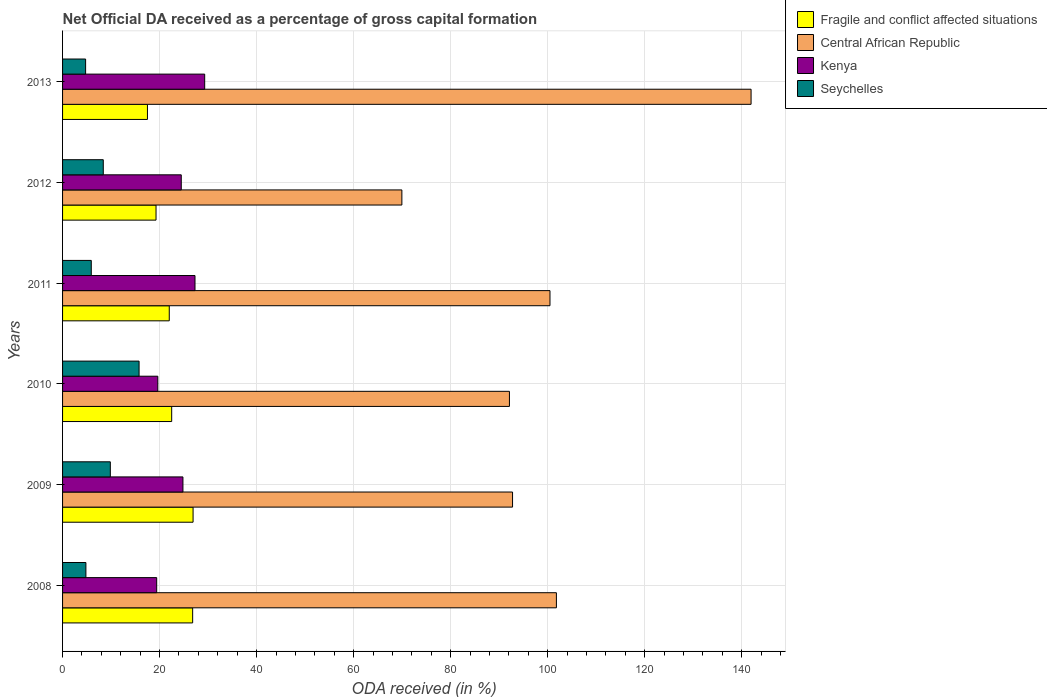How many groups of bars are there?
Ensure brevity in your answer.  6. Are the number of bars per tick equal to the number of legend labels?
Your answer should be very brief. Yes. How many bars are there on the 3rd tick from the bottom?
Offer a very short reply. 4. What is the net ODA received in Central African Republic in 2013?
Your response must be concise. 141.94. Across all years, what is the maximum net ODA received in Central African Republic?
Your answer should be very brief. 141.94. Across all years, what is the minimum net ODA received in Fragile and conflict affected situations?
Offer a very short reply. 17.5. In which year was the net ODA received in Central African Republic minimum?
Your response must be concise. 2012. What is the total net ODA received in Fragile and conflict affected situations in the graph?
Your answer should be very brief. 134.99. What is the difference between the net ODA received in Central African Republic in 2008 and that in 2009?
Offer a very short reply. 9.04. What is the difference between the net ODA received in Kenya in 2011 and the net ODA received in Central African Republic in 2012?
Provide a short and direct response. -42.65. What is the average net ODA received in Central African Republic per year?
Give a very brief answer. 99.85. In the year 2013, what is the difference between the net ODA received in Seychelles and net ODA received in Kenya?
Ensure brevity in your answer.  -24.55. In how many years, is the net ODA received in Kenya greater than 8 %?
Your answer should be very brief. 6. What is the ratio of the net ODA received in Seychelles in 2010 to that in 2013?
Offer a terse response. 3.32. Is the net ODA received in Fragile and conflict affected situations in 2010 less than that in 2013?
Your response must be concise. No. What is the difference between the highest and the second highest net ODA received in Kenya?
Offer a terse response. 2. What is the difference between the highest and the lowest net ODA received in Fragile and conflict affected situations?
Keep it short and to the point. 9.4. What does the 2nd bar from the top in 2009 represents?
Your response must be concise. Kenya. What does the 4th bar from the bottom in 2010 represents?
Ensure brevity in your answer.  Seychelles. How many bars are there?
Your answer should be compact. 24. Are all the bars in the graph horizontal?
Provide a short and direct response. Yes. How many years are there in the graph?
Ensure brevity in your answer.  6. Does the graph contain any zero values?
Keep it short and to the point. No. Where does the legend appear in the graph?
Your answer should be compact. Top right. What is the title of the graph?
Your answer should be very brief. Net Official DA received as a percentage of gross capital formation. Does "Denmark" appear as one of the legend labels in the graph?
Ensure brevity in your answer.  No. What is the label or title of the X-axis?
Make the answer very short. ODA received (in %). What is the ODA received (in %) of Fragile and conflict affected situations in 2008?
Offer a terse response. 26.82. What is the ODA received (in %) in Central African Republic in 2008?
Your answer should be very brief. 101.81. What is the ODA received (in %) of Kenya in 2008?
Ensure brevity in your answer.  19.4. What is the ODA received (in %) of Seychelles in 2008?
Offer a terse response. 4.81. What is the ODA received (in %) of Fragile and conflict affected situations in 2009?
Your answer should be very brief. 26.91. What is the ODA received (in %) in Central African Republic in 2009?
Your answer should be very brief. 92.77. What is the ODA received (in %) in Kenya in 2009?
Provide a succinct answer. 24.82. What is the ODA received (in %) of Seychelles in 2009?
Ensure brevity in your answer.  9.85. What is the ODA received (in %) in Fragile and conflict affected situations in 2010?
Offer a very short reply. 22.5. What is the ODA received (in %) of Central African Republic in 2010?
Your answer should be compact. 92.13. What is the ODA received (in %) in Kenya in 2010?
Your answer should be compact. 19.64. What is the ODA received (in %) of Seychelles in 2010?
Provide a succinct answer. 15.78. What is the ODA received (in %) of Fragile and conflict affected situations in 2011?
Your answer should be very brief. 22. What is the ODA received (in %) in Central African Republic in 2011?
Provide a short and direct response. 100.49. What is the ODA received (in %) of Kenya in 2011?
Ensure brevity in your answer.  27.3. What is the ODA received (in %) of Seychelles in 2011?
Offer a very short reply. 5.92. What is the ODA received (in %) of Fragile and conflict affected situations in 2012?
Ensure brevity in your answer.  19.27. What is the ODA received (in %) in Central African Republic in 2012?
Offer a terse response. 69.95. What is the ODA received (in %) of Kenya in 2012?
Your response must be concise. 24.47. What is the ODA received (in %) in Seychelles in 2012?
Provide a succinct answer. 8.39. What is the ODA received (in %) of Fragile and conflict affected situations in 2013?
Your answer should be compact. 17.5. What is the ODA received (in %) in Central African Republic in 2013?
Your response must be concise. 141.94. What is the ODA received (in %) in Kenya in 2013?
Offer a terse response. 29.3. What is the ODA received (in %) of Seychelles in 2013?
Provide a short and direct response. 4.75. Across all years, what is the maximum ODA received (in %) in Fragile and conflict affected situations?
Offer a very short reply. 26.91. Across all years, what is the maximum ODA received (in %) of Central African Republic?
Your answer should be very brief. 141.94. Across all years, what is the maximum ODA received (in %) in Kenya?
Provide a short and direct response. 29.3. Across all years, what is the maximum ODA received (in %) of Seychelles?
Give a very brief answer. 15.78. Across all years, what is the minimum ODA received (in %) in Fragile and conflict affected situations?
Provide a short and direct response. 17.5. Across all years, what is the minimum ODA received (in %) of Central African Republic?
Offer a terse response. 69.95. Across all years, what is the minimum ODA received (in %) in Kenya?
Provide a succinct answer. 19.4. Across all years, what is the minimum ODA received (in %) in Seychelles?
Provide a short and direct response. 4.75. What is the total ODA received (in %) of Fragile and conflict affected situations in the graph?
Provide a succinct answer. 134.99. What is the total ODA received (in %) in Central African Republic in the graph?
Offer a terse response. 599.08. What is the total ODA received (in %) of Kenya in the graph?
Your answer should be compact. 144.93. What is the total ODA received (in %) in Seychelles in the graph?
Give a very brief answer. 49.49. What is the difference between the ODA received (in %) in Fragile and conflict affected situations in 2008 and that in 2009?
Your answer should be compact. -0.09. What is the difference between the ODA received (in %) in Central African Republic in 2008 and that in 2009?
Offer a very short reply. 9.04. What is the difference between the ODA received (in %) in Kenya in 2008 and that in 2009?
Give a very brief answer. -5.41. What is the difference between the ODA received (in %) in Seychelles in 2008 and that in 2009?
Provide a short and direct response. -5.04. What is the difference between the ODA received (in %) in Fragile and conflict affected situations in 2008 and that in 2010?
Provide a succinct answer. 4.32. What is the difference between the ODA received (in %) of Central African Republic in 2008 and that in 2010?
Give a very brief answer. 9.68. What is the difference between the ODA received (in %) in Kenya in 2008 and that in 2010?
Your answer should be very brief. -0.23. What is the difference between the ODA received (in %) of Seychelles in 2008 and that in 2010?
Provide a succinct answer. -10.96. What is the difference between the ODA received (in %) in Fragile and conflict affected situations in 2008 and that in 2011?
Keep it short and to the point. 4.82. What is the difference between the ODA received (in %) in Central African Republic in 2008 and that in 2011?
Your response must be concise. 1.32. What is the difference between the ODA received (in %) of Kenya in 2008 and that in 2011?
Keep it short and to the point. -7.9. What is the difference between the ODA received (in %) of Seychelles in 2008 and that in 2011?
Your answer should be compact. -1.11. What is the difference between the ODA received (in %) in Fragile and conflict affected situations in 2008 and that in 2012?
Give a very brief answer. 7.55. What is the difference between the ODA received (in %) of Central African Republic in 2008 and that in 2012?
Offer a very short reply. 31.86. What is the difference between the ODA received (in %) of Kenya in 2008 and that in 2012?
Ensure brevity in your answer.  -5.07. What is the difference between the ODA received (in %) in Seychelles in 2008 and that in 2012?
Give a very brief answer. -3.58. What is the difference between the ODA received (in %) of Fragile and conflict affected situations in 2008 and that in 2013?
Your response must be concise. 9.32. What is the difference between the ODA received (in %) of Central African Republic in 2008 and that in 2013?
Ensure brevity in your answer.  -40.13. What is the difference between the ODA received (in %) in Kenya in 2008 and that in 2013?
Your response must be concise. -9.9. What is the difference between the ODA received (in %) of Seychelles in 2008 and that in 2013?
Make the answer very short. 0.06. What is the difference between the ODA received (in %) in Fragile and conflict affected situations in 2009 and that in 2010?
Your answer should be compact. 4.41. What is the difference between the ODA received (in %) in Central African Republic in 2009 and that in 2010?
Provide a short and direct response. 0.64. What is the difference between the ODA received (in %) of Kenya in 2009 and that in 2010?
Offer a terse response. 5.18. What is the difference between the ODA received (in %) of Seychelles in 2009 and that in 2010?
Make the answer very short. -5.93. What is the difference between the ODA received (in %) in Fragile and conflict affected situations in 2009 and that in 2011?
Offer a very short reply. 4.91. What is the difference between the ODA received (in %) of Central African Republic in 2009 and that in 2011?
Give a very brief answer. -7.72. What is the difference between the ODA received (in %) of Kenya in 2009 and that in 2011?
Provide a succinct answer. -2.48. What is the difference between the ODA received (in %) of Seychelles in 2009 and that in 2011?
Make the answer very short. 3.93. What is the difference between the ODA received (in %) of Fragile and conflict affected situations in 2009 and that in 2012?
Give a very brief answer. 7.64. What is the difference between the ODA received (in %) of Central African Republic in 2009 and that in 2012?
Ensure brevity in your answer.  22.82. What is the difference between the ODA received (in %) of Kenya in 2009 and that in 2012?
Your answer should be very brief. 0.34. What is the difference between the ODA received (in %) of Seychelles in 2009 and that in 2012?
Provide a succinct answer. 1.45. What is the difference between the ODA received (in %) in Fragile and conflict affected situations in 2009 and that in 2013?
Your answer should be very brief. 9.4. What is the difference between the ODA received (in %) of Central African Republic in 2009 and that in 2013?
Provide a succinct answer. -49.18. What is the difference between the ODA received (in %) in Kenya in 2009 and that in 2013?
Your answer should be compact. -4.48. What is the difference between the ODA received (in %) in Seychelles in 2009 and that in 2013?
Make the answer very short. 5.1. What is the difference between the ODA received (in %) of Fragile and conflict affected situations in 2010 and that in 2011?
Provide a short and direct response. 0.5. What is the difference between the ODA received (in %) of Central African Republic in 2010 and that in 2011?
Your answer should be compact. -8.36. What is the difference between the ODA received (in %) of Kenya in 2010 and that in 2011?
Offer a very short reply. -7.67. What is the difference between the ODA received (in %) of Seychelles in 2010 and that in 2011?
Give a very brief answer. 9.86. What is the difference between the ODA received (in %) of Fragile and conflict affected situations in 2010 and that in 2012?
Your answer should be very brief. 3.23. What is the difference between the ODA received (in %) of Central African Republic in 2010 and that in 2012?
Offer a terse response. 22.18. What is the difference between the ODA received (in %) of Kenya in 2010 and that in 2012?
Keep it short and to the point. -4.84. What is the difference between the ODA received (in %) in Seychelles in 2010 and that in 2012?
Keep it short and to the point. 7.38. What is the difference between the ODA received (in %) in Fragile and conflict affected situations in 2010 and that in 2013?
Keep it short and to the point. 4.99. What is the difference between the ODA received (in %) in Central African Republic in 2010 and that in 2013?
Ensure brevity in your answer.  -49.82. What is the difference between the ODA received (in %) in Kenya in 2010 and that in 2013?
Keep it short and to the point. -9.66. What is the difference between the ODA received (in %) of Seychelles in 2010 and that in 2013?
Your answer should be very brief. 11.03. What is the difference between the ODA received (in %) in Fragile and conflict affected situations in 2011 and that in 2012?
Give a very brief answer. 2.73. What is the difference between the ODA received (in %) in Central African Republic in 2011 and that in 2012?
Provide a succinct answer. 30.54. What is the difference between the ODA received (in %) of Kenya in 2011 and that in 2012?
Keep it short and to the point. 2.83. What is the difference between the ODA received (in %) in Seychelles in 2011 and that in 2012?
Provide a succinct answer. -2.48. What is the difference between the ODA received (in %) of Fragile and conflict affected situations in 2011 and that in 2013?
Offer a terse response. 4.5. What is the difference between the ODA received (in %) of Central African Republic in 2011 and that in 2013?
Your answer should be very brief. -41.46. What is the difference between the ODA received (in %) of Kenya in 2011 and that in 2013?
Offer a terse response. -2. What is the difference between the ODA received (in %) in Seychelles in 2011 and that in 2013?
Your answer should be compact. 1.17. What is the difference between the ODA received (in %) in Fragile and conflict affected situations in 2012 and that in 2013?
Offer a very short reply. 1.77. What is the difference between the ODA received (in %) of Central African Republic in 2012 and that in 2013?
Give a very brief answer. -71.99. What is the difference between the ODA received (in %) in Kenya in 2012 and that in 2013?
Keep it short and to the point. -4.83. What is the difference between the ODA received (in %) in Seychelles in 2012 and that in 2013?
Give a very brief answer. 3.64. What is the difference between the ODA received (in %) of Fragile and conflict affected situations in 2008 and the ODA received (in %) of Central African Republic in 2009?
Make the answer very short. -65.95. What is the difference between the ODA received (in %) in Fragile and conflict affected situations in 2008 and the ODA received (in %) in Kenya in 2009?
Your response must be concise. 2. What is the difference between the ODA received (in %) of Fragile and conflict affected situations in 2008 and the ODA received (in %) of Seychelles in 2009?
Your answer should be very brief. 16.97. What is the difference between the ODA received (in %) in Central African Republic in 2008 and the ODA received (in %) in Kenya in 2009?
Give a very brief answer. 76.99. What is the difference between the ODA received (in %) of Central African Republic in 2008 and the ODA received (in %) of Seychelles in 2009?
Provide a succinct answer. 91.96. What is the difference between the ODA received (in %) of Kenya in 2008 and the ODA received (in %) of Seychelles in 2009?
Keep it short and to the point. 9.56. What is the difference between the ODA received (in %) in Fragile and conflict affected situations in 2008 and the ODA received (in %) in Central African Republic in 2010?
Provide a succinct answer. -65.31. What is the difference between the ODA received (in %) in Fragile and conflict affected situations in 2008 and the ODA received (in %) in Kenya in 2010?
Your answer should be very brief. 7.18. What is the difference between the ODA received (in %) in Fragile and conflict affected situations in 2008 and the ODA received (in %) in Seychelles in 2010?
Ensure brevity in your answer.  11.04. What is the difference between the ODA received (in %) in Central African Republic in 2008 and the ODA received (in %) in Kenya in 2010?
Ensure brevity in your answer.  82.17. What is the difference between the ODA received (in %) of Central African Republic in 2008 and the ODA received (in %) of Seychelles in 2010?
Make the answer very short. 86.03. What is the difference between the ODA received (in %) of Kenya in 2008 and the ODA received (in %) of Seychelles in 2010?
Provide a short and direct response. 3.63. What is the difference between the ODA received (in %) in Fragile and conflict affected situations in 2008 and the ODA received (in %) in Central African Republic in 2011?
Keep it short and to the point. -73.67. What is the difference between the ODA received (in %) in Fragile and conflict affected situations in 2008 and the ODA received (in %) in Kenya in 2011?
Give a very brief answer. -0.48. What is the difference between the ODA received (in %) of Fragile and conflict affected situations in 2008 and the ODA received (in %) of Seychelles in 2011?
Your response must be concise. 20.9. What is the difference between the ODA received (in %) of Central African Republic in 2008 and the ODA received (in %) of Kenya in 2011?
Give a very brief answer. 74.51. What is the difference between the ODA received (in %) of Central African Republic in 2008 and the ODA received (in %) of Seychelles in 2011?
Keep it short and to the point. 95.89. What is the difference between the ODA received (in %) of Kenya in 2008 and the ODA received (in %) of Seychelles in 2011?
Provide a succinct answer. 13.48. What is the difference between the ODA received (in %) of Fragile and conflict affected situations in 2008 and the ODA received (in %) of Central African Republic in 2012?
Make the answer very short. -43.13. What is the difference between the ODA received (in %) of Fragile and conflict affected situations in 2008 and the ODA received (in %) of Kenya in 2012?
Offer a very short reply. 2.35. What is the difference between the ODA received (in %) of Fragile and conflict affected situations in 2008 and the ODA received (in %) of Seychelles in 2012?
Your answer should be very brief. 18.43. What is the difference between the ODA received (in %) in Central African Republic in 2008 and the ODA received (in %) in Kenya in 2012?
Make the answer very short. 77.34. What is the difference between the ODA received (in %) in Central African Republic in 2008 and the ODA received (in %) in Seychelles in 2012?
Keep it short and to the point. 93.42. What is the difference between the ODA received (in %) of Kenya in 2008 and the ODA received (in %) of Seychelles in 2012?
Give a very brief answer. 11.01. What is the difference between the ODA received (in %) in Fragile and conflict affected situations in 2008 and the ODA received (in %) in Central African Republic in 2013?
Your response must be concise. -115.12. What is the difference between the ODA received (in %) in Fragile and conflict affected situations in 2008 and the ODA received (in %) in Kenya in 2013?
Your answer should be very brief. -2.48. What is the difference between the ODA received (in %) in Fragile and conflict affected situations in 2008 and the ODA received (in %) in Seychelles in 2013?
Your answer should be very brief. 22.07. What is the difference between the ODA received (in %) of Central African Republic in 2008 and the ODA received (in %) of Kenya in 2013?
Provide a succinct answer. 72.51. What is the difference between the ODA received (in %) in Central African Republic in 2008 and the ODA received (in %) in Seychelles in 2013?
Provide a short and direct response. 97.06. What is the difference between the ODA received (in %) of Kenya in 2008 and the ODA received (in %) of Seychelles in 2013?
Your response must be concise. 14.65. What is the difference between the ODA received (in %) of Fragile and conflict affected situations in 2009 and the ODA received (in %) of Central African Republic in 2010?
Keep it short and to the point. -65.22. What is the difference between the ODA received (in %) of Fragile and conflict affected situations in 2009 and the ODA received (in %) of Kenya in 2010?
Your response must be concise. 7.27. What is the difference between the ODA received (in %) in Fragile and conflict affected situations in 2009 and the ODA received (in %) in Seychelles in 2010?
Offer a terse response. 11.13. What is the difference between the ODA received (in %) of Central African Republic in 2009 and the ODA received (in %) of Kenya in 2010?
Give a very brief answer. 73.13. What is the difference between the ODA received (in %) in Central African Republic in 2009 and the ODA received (in %) in Seychelles in 2010?
Provide a succinct answer. 76.99. What is the difference between the ODA received (in %) in Kenya in 2009 and the ODA received (in %) in Seychelles in 2010?
Give a very brief answer. 9.04. What is the difference between the ODA received (in %) of Fragile and conflict affected situations in 2009 and the ODA received (in %) of Central African Republic in 2011?
Give a very brief answer. -73.58. What is the difference between the ODA received (in %) in Fragile and conflict affected situations in 2009 and the ODA received (in %) in Kenya in 2011?
Give a very brief answer. -0.4. What is the difference between the ODA received (in %) of Fragile and conflict affected situations in 2009 and the ODA received (in %) of Seychelles in 2011?
Your answer should be very brief. 20.99. What is the difference between the ODA received (in %) in Central African Republic in 2009 and the ODA received (in %) in Kenya in 2011?
Provide a succinct answer. 65.47. What is the difference between the ODA received (in %) of Central African Republic in 2009 and the ODA received (in %) of Seychelles in 2011?
Your answer should be compact. 86.85. What is the difference between the ODA received (in %) in Kenya in 2009 and the ODA received (in %) in Seychelles in 2011?
Provide a succinct answer. 18.9. What is the difference between the ODA received (in %) of Fragile and conflict affected situations in 2009 and the ODA received (in %) of Central African Republic in 2012?
Offer a very short reply. -43.04. What is the difference between the ODA received (in %) in Fragile and conflict affected situations in 2009 and the ODA received (in %) in Kenya in 2012?
Your response must be concise. 2.43. What is the difference between the ODA received (in %) of Fragile and conflict affected situations in 2009 and the ODA received (in %) of Seychelles in 2012?
Your answer should be compact. 18.51. What is the difference between the ODA received (in %) of Central African Republic in 2009 and the ODA received (in %) of Kenya in 2012?
Offer a very short reply. 68.29. What is the difference between the ODA received (in %) in Central African Republic in 2009 and the ODA received (in %) in Seychelles in 2012?
Provide a succinct answer. 84.37. What is the difference between the ODA received (in %) of Kenya in 2009 and the ODA received (in %) of Seychelles in 2012?
Your response must be concise. 16.42. What is the difference between the ODA received (in %) of Fragile and conflict affected situations in 2009 and the ODA received (in %) of Central African Republic in 2013?
Your response must be concise. -115.04. What is the difference between the ODA received (in %) in Fragile and conflict affected situations in 2009 and the ODA received (in %) in Kenya in 2013?
Your answer should be very brief. -2.39. What is the difference between the ODA received (in %) in Fragile and conflict affected situations in 2009 and the ODA received (in %) in Seychelles in 2013?
Give a very brief answer. 22.16. What is the difference between the ODA received (in %) of Central African Republic in 2009 and the ODA received (in %) of Kenya in 2013?
Provide a short and direct response. 63.47. What is the difference between the ODA received (in %) of Central African Republic in 2009 and the ODA received (in %) of Seychelles in 2013?
Provide a short and direct response. 88.02. What is the difference between the ODA received (in %) in Kenya in 2009 and the ODA received (in %) in Seychelles in 2013?
Give a very brief answer. 20.07. What is the difference between the ODA received (in %) of Fragile and conflict affected situations in 2010 and the ODA received (in %) of Central African Republic in 2011?
Offer a very short reply. -77.99. What is the difference between the ODA received (in %) in Fragile and conflict affected situations in 2010 and the ODA received (in %) in Kenya in 2011?
Provide a succinct answer. -4.81. What is the difference between the ODA received (in %) of Fragile and conflict affected situations in 2010 and the ODA received (in %) of Seychelles in 2011?
Provide a succinct answer. 16.58. What is the difference between the ODA received (in %) in Central African Republic in 2010 and the ODA received (in %) in Kenya in 2011?
Provide a succinct answer. 64.82. What is the difference between the ODA received (in %) of Central African Republic in 2010 and the ODA received (in %) of Seychelles in 2011?
Keep it short and to the point. 86.21. What is the difference between the ODA received (in %) of Kenya in 2010 and the ODA received (in %) of Seychelles in 2011?
Offer a very short reply. 13.72. What is the difference between the ODA received (in %) of Fragile and conflict affected situations in 2010 and the ODA received (in %) of Central African Republic in 2012?
Provide a succinct answer. -47.45. What is the difference between the ODA received (in %) in Fragile and conflict affected situations in 2010 and the ODA received (in %) in Kenya in 2012?
Keep it short and to the point. -1.98. What is the difference between the ODA received (in %) of Fragile and conflict affected situations in 2010 and the ODA received (in %) of Seychelles in 2012?
Ensure brevity in your answer.  14.1. What is the difference between the ODA received (in %) of Central African Republic in 2010 and the ODA received (in %) of Kenya in 2012?
Your answer should be very brief. 67.65. What is the difference between the ODA received (in %) of Central African Republic in 2010 and the ODA received (in %) of Seychelles in 2012?
Your answer should be compact. 83.73. What is the difference between the ODA received (in %) in Kenya in 2010 and the ODA received (in %) in Seychelles in 2012?
Your response must be concise. 11.24. What is the difference between the ODA received (in %) of Fragile and conflict affected situations in 2010 and the ODA received (in %) of Central African Republic in 2013?
Offer a terse response. -119.45. What is the difference between the ODA received (in %) of Fragile and conflict affected situations in 2010 and the ODA received (in %) of Kenya in 2013?
Your answer should be compact. -6.8. What is the difference between the ODA received (in %) in Fragile and conflict affected situations in 2010 and the ODA received (in %) in Seychelles in 2013?
Offer a very short reply. 17.75. What is the difference between the ODA received (in %) in Central African Republic in 2010 and the ODA received (in %) in Kenya in 2013?
Provide a succinct answer. 62.83. What is the difference between the ODA received (in %) in Central African Republic in 2010 and the ODA received (in %) in Seychelles in 2013?
Provide a short and direct response. 87.38. What is the difference between the ODA received (in %) in Kenya in 2010 and the ODA received (in %) in Seychelles in 2013?
Your response must be concise. 14.89. What is the difference between the ODA received (in %) in Fragile and conflict affected situations in 2011 and the ODA received (in %) in Central African Republic in 2012?
Ensure brevity in your answer.  -47.95. What is the difference between the ODA received (in %) of Fragile and conflict affected situations in 2011 and the ODA received (in %) of Kenya in 2012?
Offer a terse response. -2.48. What is the difference between the ODA received (in %) of Fragile and conflict affected situations in 2011 and the ODA received (in %) of Seychelles in 2012?
Keep it short and to the point. 13.6. What is the difference between the ODA received (in %) of Central African Republic in 2011 and the ODA received (in %) of Kenya in 2012?
Your answer should be compact. 76.01. What is the difference between the ODA received (in %) of Central African Republic in 2011 and the ODA received (in %) of Seychelles in 2012?
Give a very brief answer. 92.09. What is the difference between the ODA received (in %) of Kenya in 2011 and the ODA received (in %) of Seychelles in 2012?
Provide a short and direct response. 18.91. What is the difference between the ODA received (in %) of Fragile and conflict affected situations in 2011 and the ODA received (in %) of Central African Republic in 2013?
Offer a very short reply. -119.95. What is the difference between the ODA received (in %) in Fragile and conflict affected situations in 2011 and the ODA received (in %) in Kenya in 2013?
Offer a very short reply. -7.3. What is the difference between the ODA received (in %) in Fragile and conflict affected situations in 2011 and the ODA received (in %) in Seychelles in 2013?
Your answer should be very brief. 17.25. What is the difference between the ODA received (in %) in Central African Republic in 2011 and the ODA received (in %) in Kenya in 2013?
Ensure brevity in your answer.  71.19. What is the difference between the ODA received (in %) of Central African Republic in 2011 and the ODA received (in %) of Seychelles in 2013?
Give a very brief answer. 95.74. What is the difference between the ODA received (in %) of Kenya in 2011 and the ODA received (in %) of Seychelles in 2013?
Keep it short and to the point. 22.55. What is the difference between the ODA received (in %) in Fragile and conflict affected situations in 2012 and the ODA received (in %) in Central African Republic in 2013?
Provide a succinct answer. -122.67. What is the difference between the ODA received (in %) in Fragile and conflict affected situations in 2012 and the ODA received (in %) in Kenya in 2013?
Keep it short and to the point. -10.03. What is the difference between the ODA received (in %) in Fragile and conflict affected situations in 2012 and the ODA received (in %) in Seychelles in 2013?
Make the answer very short. 14.52. What is the difference between the ODA received (in %) in Central African Republic in 2012 and the ODA received (in %) in Kenya in 2013?
Ensure brevity in your answer.  40.65. What is the difference between the ODA received (in %) in Central African Republic in 2012 and the ODA received (in %) in Seychelles in 2013?
Keep it short and to the point. 65.2. What is the difference between the ODA received (in %) of Kenya in 2012 and the ODA received (in %) of Seychelles in 2013?
Your answer should be very brief. 19.72. What is the average ODA received (in %) of Fragile and conflict affected situations per year?
Your answer should be compact. 22.5. What is the average ODA received (in %) in Central African Republic per year?
Your answer should be very brief. 99.85. What is the average ODA received (in %) of Kenya per year?
Provide a short and direct response. 24.15. What is the average ODA received (in %) in Seychelles per year?
Keep it short and to the point. 8.25. In the year 2008, what is the difference between the ODA received (in %) in Fragile and conflict affected situations and ODA received (in %) in Central African Republic?
Provide a succinct answer. -74.99. In the year 2008, what is the difference between the ODA received (in %) in Fragile and conflict affected situations and ODA received (in %) in Kenya?
Provide a short and direct response. 7.42. In the year 2008, what is the difference between the ODA received (in %) of Fragile and conflict affected situations and ODA received (in %) of Seychelles?
Make the answer very short. 22.01. In the year 2008, what is the difference between the ODA received (in %) of Central African Republic and ODA received (in %) of Kenya?
Your answer should be very brief. 82.41. In the year 2008, what is the difference between the ODA received (in %) in Central African Republic and ODA received (in %) in Seychelles?
Provide a succinct answer. 97. In the year 2008, what is the difference between the ODA received (in %) of Kenya and ODA received (in %) of Seychelles?
Offer a very short reply. 14.59. In the year 2009, what is the difference between the ODA received (in %) in Fragile and conflict affected situations and ODA received (in %) in Central African Republic?
Offer a very short reply. -65.86. In the year 2009, what is the difference between the ODA received (in %) in Fragile and conflict affected situations and ODA received (in %) in Kenya?
Your response must be concise. 2.09. In the year 2009, what is the difference between the ODA received (in %) in Fragile and conflict affected situations and ODA received (in %) in Seychelles?
Offer a very short reply. 17.06. In the year 2009, what is the difference between the ODA received (in %) in Central African Republic and ODA received (in %) in Kenya?
Your answer should be compact. 67.95. In the year 2009, what is the difference between the ODA received (in %) in Central African Republic and ODA received (in %) in Seychelles?
Your response must be concise. 82.92. In the year 2009, what is the difference between the ODA received (in %) in Kenya and ODA received (in %) in Seychelles?
Make the answer very short. 14.97. In the year 2010, what is the difference between the ODA received (in %) in Fragile and conflict affected situations and ODA received (in %) in Central African Republic?
Provide a short and direct response. -69.63. In the year 2010, what is the difference between the ODA received (in %) of Fragile and conflict affected situations and ODA received (in %) of Kenya?
Your response must be concise. 2.86. In the year 2010, what is the difference between the ODA received (in %) in Fragile and conflict affected situations and ODA received (in %) in Seychelles?
Make the answer very short. 6.72. In the year 2010, what is the difference between the ODA received (in %) in Central African Republic and ODA received (in %) in Kenya?
Give a very brief answer. 72.49. In the year 2010, what is the difference between the ODA received (in %) of Central African Republic and ODA received (in %) of Seychelles?
Offer a very short reply. 76.35. In the year 2010, what is the difference between the ODA received (in %) in Kenya and ODA received (in %) in Seychelles?
Make the answer very short. 3.86. In the year 2011, what is the difference between the ODA received (in %) of Fragile and conflict affected situations and ODA received (in %) of Central African Republic?
Offer a very short reply. -78.49. In the year 2011, what is the difference between the ODA received (in %) of Fragile and conflict affected situations and ODA received (in %) of Kenya?
Give a very brief answer. -5.31. In the year 2011, what is the difference between the ODA received (in %) in Fragile and conflict affected situations and ODA received (in %) in Seychelles?
Your answer should be very brief. 16.08. In the year 2011, what is the difference between the ODA received (in %) of Central African Republic and ODA received (in %) of Kenya?
Make the answer very short. 73.19. In the year 2011, what is the difference between the ODA received (in %) of Central African Republic and ODA received (in %) of Seychelles?
Provide a succinct answer. 94.57. In the year 2011, what is the difference between the ODA received (in %) in Kenya and ODA received (in %) in Seychelles?
Give a very brief answer. 21.38. In the year 2012, what is the difference between the ODA received (in %) of Fragile and conflict affected situations and ODA received (in %) of Central African Republic?
Your response must be concise. -50.68. In the year 2012, what is the difference between the ODA received (in %) of Fragile and conflict affected situations and ODA received (in %) of Kenya?
Offer a very short reply. -5.2. In the year 2012, what is the difference between the ODA received (in %) in Fragile and conflict affected situations and ODA received (in %) in Seychelles?
Your response must be concise. 10.87. In the year 2012, what is the difference between the ODA received (in %) in Central African Republic and ODA received (in %) in Kenya?
Provide a succinct answer. 45.48. In the year 2012, what is the difference between the ODA received (in %) of Central African Republic and ODA received (in %) of Seychelles?
Offer a terse response. 61.56. In the year 2012, what is the difference between the ODA received (in %) of Kenya and ODA received (in %) of Seychelles?
Give a very brief answer. 16.08. In the year 2013, what is the difference between the ODA received (in %) in Fragile and conflict affected situations and ODA received (in %) in Central African Republic?
Make the answer very short. -124.44. In the year 2013, what is the difference between the ODA received (in %) of Fragile and conflict affected situations and ODA received (in %) of Kenya?
Your answer should be very brief. -11.8. In the year 2013, what is the difference between the ODA received (in %) of Fragile and conflict affected situations and ODA received (in %) of Seychelles?
Provide a succinct answer. 12.75. In the year 2013, what is the difference between the ODA received (in %) of Central African Republic and ODA received (in %) of Kenya?
Provide a succinct answer. 112.64. In the year 2013, what is the difference between the ODA received (in %) in Central African Republic and ODA received (in %) in Seychelles?
Your answer should be compact. 137.19. In the year 2013, what is the difference between the ODA received (in %) in Kenya and ODA received (in %) in Seychelles?
Make the answer very short. 24.55. What is the ratio of the ODA received (in %) of Fragile and conflict affected situations in 2008 to that in 2009?
Provide a succinct answer. 1. What is the ratio of the ODA received (in %) in Central African Republic in 2008 to that in 2009?
Your answer should be compact. 1.1. What is the ratio of the ODA received (in %) in Kenya in 2008 to that in 2009?
Provide a succinct answer. 0.78. What is the ratio of the ODA received (in %) in Seychelles in 2008 to that in 2009?
Provide a succinct answer. 0.49. What is the ratio of the ODA received (in %) in Fragile and conflict affected situations in 2008 to that in 2010?
Provide a succinct answer. 1.19. What is the ratio of the ODA received (in %) in Central African Republic in 2008 to that in 2010?
Provide a succinct answer. 1.11. What is the ratio of the ODA received (in %) of Seychelles in 2008 to that in 2010?
Provide a succinct answer. 0.3. What is the ratio of the ODA received (in %) of Fragile and conflict affected situations in 2008 to that in 2011?
Your answer should be very brief. 1.22. What is the ratio of the ODA received (in %) in Central African Republic in 2008 to that in 2011?
Offer a very short reply. 1.01. What is the ratio of the ODA received (in %) of Kenya in 2008 to that in 2011?
Ensure brevity in your answer.  0.71. What is the ratio of the ODA received (in %) of Seychelles in 2008 to that in 2011?
Your answer should be compact. 0.81. What is the ratio of the ODA received (in %) in Fragile and conflict affected situations in 2008 to that in 2012?
Make the answer very short. 1.39. What is the ratio of the ODA received (in %) of Central African Republic in 2008 to that in 2012?
Your answer should be very brief. 1.46. What is the ratio of the ODA received (in %) of Kenya in 2008 to that in 2012?
Keep it short and to the point. 0.79. What is the ratio of the ODA received (in %) in Seychelles in 2008 to that in 2012?
Provide a short and direct response. 0.57. What is the ratio of the ODA received (in %) of Fragile and conflict affected situations in 2008 to that in 2013?
Provide a succinct answer. 1.53. What is the ratio of the ODA received (in %) of Central African Republic in 2008 to that in 2013?
Your answer should be compact. 0.72. What is the ratio of the ODA received (in %) in Kenya in 2008 to that in 2013?
Offer a very short reply. 0.66. What is the ratio of the ODA received (in %) in Seychelles in 2008 to that in 2013?
Make the answer very short. 1.01. What is the ratio of the ODA received (in %) of Fragile and conflict affected situations in 2009 to that in 2010?
Offer a very short reply. 1.2. What is the ratio of the ODA received (in %) of Kenya in 2009 to that in 2010?
Offer a terse response. 1.26. What is the ratio of the ODA received (in %) in Seychelles in 2009 to that in 2010?
Offer a very short reply. 0.62. What is the ratio of the ODA received (in %) in Fragile and conflict affected situations in 2009 to that in 2011?
Keep it short and to the point. 1.22. What is the ratio of the ODA received (in %) of Central African Republic in 2009 to that in 2011?
Your response must be concise. 0.92. What is the ratio of the ODA received (in %) in Kenya in 2009 to that in 2011?
Provide a short and direct response. 0.91. What is the ratio of the ODA received (in %) in Seychelles in 2009 to that in 2011?
Offer a very short reply. 1.66. What is the ratio of the ODA received (in %) in Fragile and conflict affected situations in 2009 to that in 2012?
Make the answer very short. 1.4. What is the ratio of the ODA received (in %) in Central African Republic in 2009 to that in 2012?
Your answer should be compact. 1.33. What is the ratio of the ODA received (in %) of Kenya in 2009 to that in 2012?
Offer a very short reply. 1.01. What is the ratio of the ODA received (in %) in Seychelles in 2009 to that in 2012?
Your response must be concise. 1.17. What is the ratio of the ODA received (in %) of Fragile and conflict affected situations in 2009 to that in 2013?
Your response must be concise. 1.54. What is the ratio of the ODA received (in %) in Central African Republic in 2009 to that in 2013?
Give a very brief answer. 0.65. What is the ratio of the ODA received (in %) in Kenya in 2009 to that in 2013?
Give a very brief answer. 0.85. What is the ratio of the ODA received (in %) of Seychelles in 2009 to that in 2013?
Give a very brief answer. 2.07. What is the ratio of the ODA received (in %) in Fragile and conflict affected situations in 2010 to that in 2011?
Offer a terse response. 1.02. What is the ratio of the ODA received (in %) in Central African Republic in 2010 to that in 2011?
Your response must be concise. 0.92. What is the ratio of the ODA received (in %) in Kenya in 2010 to that in 2011?
Keep it short and to the point. 0.72. What is the ratio of the ODA received (in %) of Seychelles in 2010 to that in 2011?
Offer a terse response. 2.67. What is the ratio of the ODA received (in %) in Fragile and conflict affected situations in 2010 to that in 2012?
Your answer should be compact. 1.17. What is the ratio of the ODA received (in %) of Central African Republic in 2010 to that in 2012?
Provide a short and direct response. 1.32. What is the ratio of the ODA received (in %) in Kenya in 2010 to that in 2012?
Your answer should be compact. 0.8. What is the ratio of the ODA received (in %) of Seychelles in 2010 to that in 2012?
Offer a terse response. 1.88. What is the ratio of the ODA received (in %) of Fragile and conflict affected situations in 2010 to that in 2013?
Provide a short and direct response. 1.29. What is the ratio of the ODA received (in %) of Central African Republic in 2010 to that in 2013?
Keep it short and to the point. 0.65. What is the ratio of the ODA received (in %) in Kenya in 2010 to that in 2013?
Your answer should be very brief. 0.67. What is the ratio of the ODA received (in %) in Seychelles in 2010 to that in 2013?
Your answer should be compact. 3.32. What is the ratio of the ODA received (in %) in Fragile and conflict affected situations in 2011 to that in 2012?
Keep it short and to the point. 1.14. What is the ratio of the ODA received (in %) in Central African Republic in 2011 to that in 2012?
Offer a terse response. 1.44. What is the ratio of the ODA received (in %) of Kenya in 2011 to that in 2012?
Offer a very short reply. 1.12. What is the ratio of the ODA received (in %) in Seychelles in 2011 to that in 2012?
Offer a terse response. 0.71. What is the ratio of the ODA received (in %) of Fragile and conflict affected situations in 2011 to that in 2013?
Your answer should be compact. 1.26. What is the ratio of the ODA received (in %) of Central African Republic in 2011 to that in 2013?
Your answer should be very brief. 0.71. What is the ratio of the ODA received (in %) of Kenya in 2011 to that in 2013?
Your answer should be very brief. 0.93. What is the ratio of the ODA received (in %) in Seychelles in 2011 to that in 2013?
Offer a very short reply. 1.25. What is the ratio of the ODA received (in %) in Fragile and conflict affected situations in 2012 to that in 2013?
Provide a short and direct response. 1.1. What is the ratio of the ODA received (in %) in Central African Republic in 2012 to that in 2013?
Provide a succinct answer. 0.49. What is the ratio of the ODA received (in %) of Kenya in 2012 to that in 2013?
Your answer should be compact. 0.84. What is the ratio of the ODA received (in %) in Seychelles in 2012 to that in 2013?
Your response must be concise. 1.77. What is the difference between the highest and the second highest ODA received (in %) of Fragile and conflict affected situations?
Offer a terse response. 0.09. What is the difference between the highest and the second highest ODA received (in %) of Central African Republic?
Make the answer very short. 40.13. What is the difference between the highest and the second highest ODA received (in %) of Kenya?
Offer a terse response. 2. What is the difference between the highest and the second highest ODA received (in %) of Seychelles?
Your answer should be compact. 5.93. What is the difference between the highest and the lowest ODA received (in %) in Fragile and conflict affected situations?
Your answer should be very brief. 9.4. What is the difference between the highest and the lowest ODA received (in %) in Central African Republic?
Your answer should be very brief. 71.99. What is the difference between the highest and the lowest ODA received (in %) in Kenya?
Your response must be concise. 9.9. What is the difference between the highest and the lowest ODA received (in %) in Seychelles?
Make the answer very short. 11.03. 